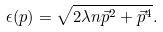Convert formula to latex. <formula><loc_0><loc_0><loc_500><loc_500>\epsilon ( p ) = \sqrt { 2 \lambda n \vec { p } ^ { 2 } + \vec { p } ^ { 4 } } .</formula> 